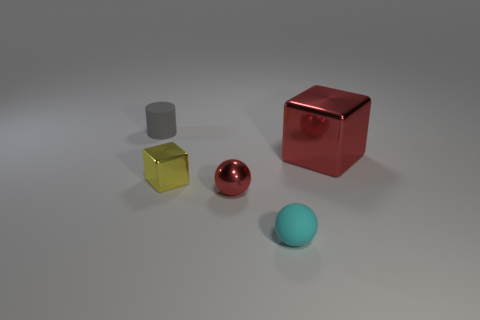What is the size of the object that is the same color as the big shiny cube?
Your response must be concise. Small. What is the shape of the cyan thing?
Provide a short and direct response. Sphere. What number of small red balls are made of the same material as the gray cylinder?
Provide a short and direct response. 0. The big thing that is made of the same material as the red sphere is what color?
Provide a succinct answer. Red. Do the matte sphere and the red shiny object that is behind the small red shiny sphere have the same size?
Provide a short and direct response. No. The ball that is in front of the tiny ball on the left side of the small rubber thing that is on the right side of the tiny cylinder is made of what material?
Ensure brevity in your answer.  Rubber. What number of objects are either red cubes or large brown cubes?
Provide a short and direct response. 1. There is a metal thing to the left of the small red ball; is it the same color as the tiny object that is on the right side of the red sphere?
Make the answer very short. No. There is a gray matte thing that is the same size as the cyan matte ball; what shape is it?
Offer a very short reply. Cylinder. How many things are balls right of the shiny ball or objects in front of the gray rubber cylinder?
Offer a very short reply. 4. 